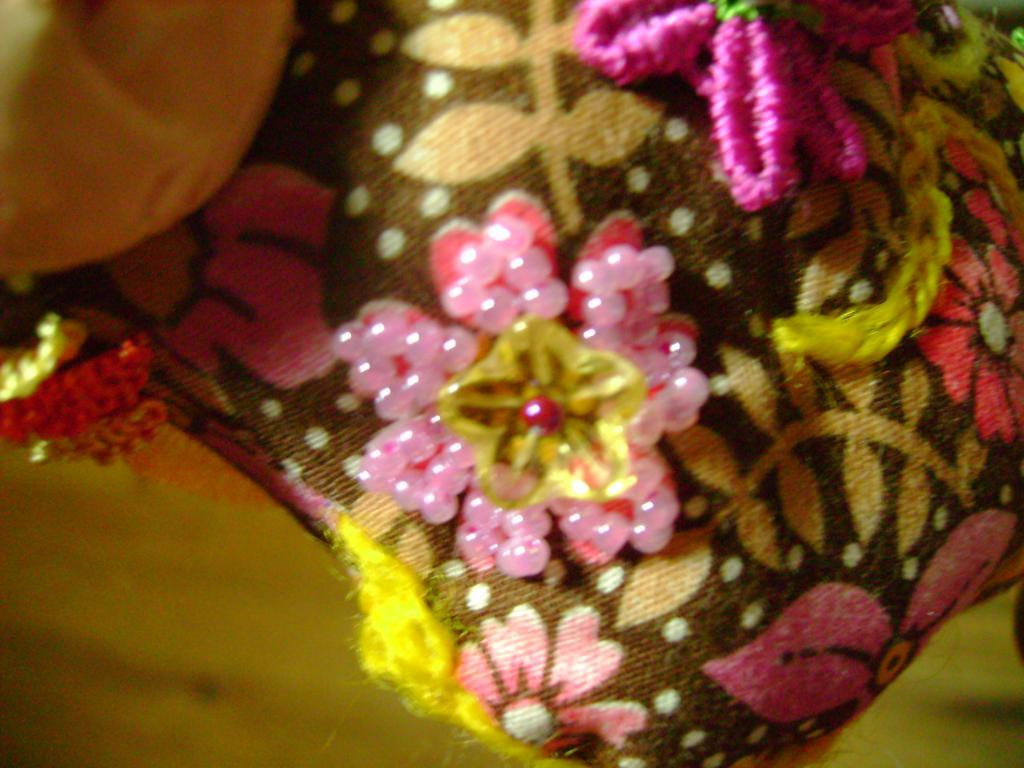What is the dog playing with in the image? The dog is playing with a ball in the image. Where is the dog playing in the image? The dog is playing in a garden in the image. What can be seen in the garden besides the dog and the ball? There are flowers and trees in the garden in the image. What type of bread is the dog using to brush its teeth in the image? There is no bread or toothbrushing activity depicted in the image; the dog is simply playing with a ball in a garden. 